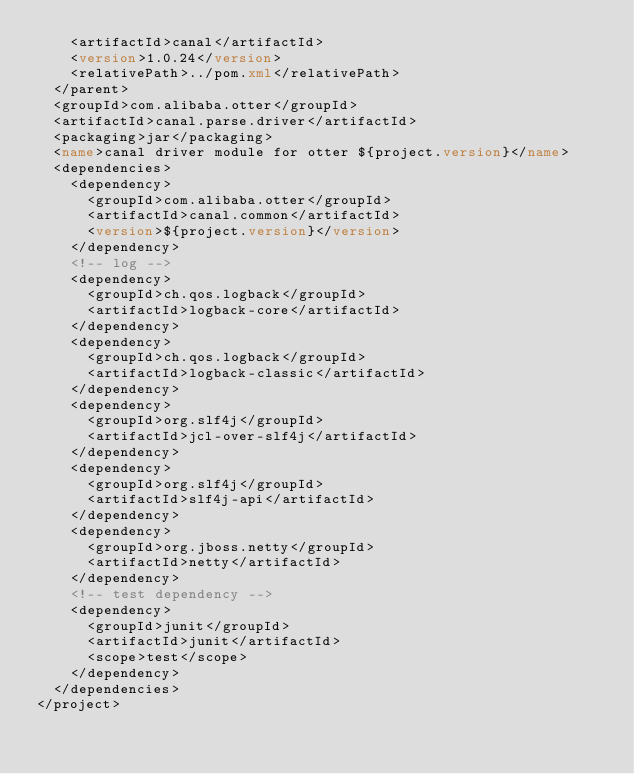Convert code to text. <code><loc_0><loc_0><loc_500><loc_500><_XML_>		<artifactId>canal</artifactId>
		<version>1.0.24</version>
		<relativePath>../pom.xml</relativePath>
	</parent>
	<groupId>com.alibaba.otter</groupId>
	<artifactId>canal.parse.driver</artifactId>
	<packaging>jar</packaging>
	<name>canal driver module for otter ${project.version}</name>
	<dependencies>
		<dependency>
			<groupId>com.alibaba.otter</groupId>
			<artifactId>canal.common</artifactId>
			<version>${project.version}</version>
		</dependency>
		<!-- log -->
		<dependency>
			<groupId>ch.qos.logback</groupId>
			<artifactId>logback-core</artifactId>
		</dependency>
		<dependency>
			<groupId>ch.qos.logback</groupId>
			<artifactId>logback-classic</artifactId>
		</dependency>
		<dependency>
			<groupId>org.slf4j</groupId>
			<artifactId>jcl-over-slf4j</artifactId>
		</dependency>
		<dependency>
			<groupId>org.slf4j</groupId>
			<artifactId>slf4j-api</artifactId>
		</dependency>
		<dependency>
			<groupId>org.jboss.netty</groupId>
			<artifactId>netty</artifactId>
		</dependency>
		<!-- test dependency -->
		<dependency>
			<groupId>junit</groupId>
			<artifactId>junit</artifactId>
			<scope>test</scope>
		</dependency>
	</dependencies>
</project>
</code> 